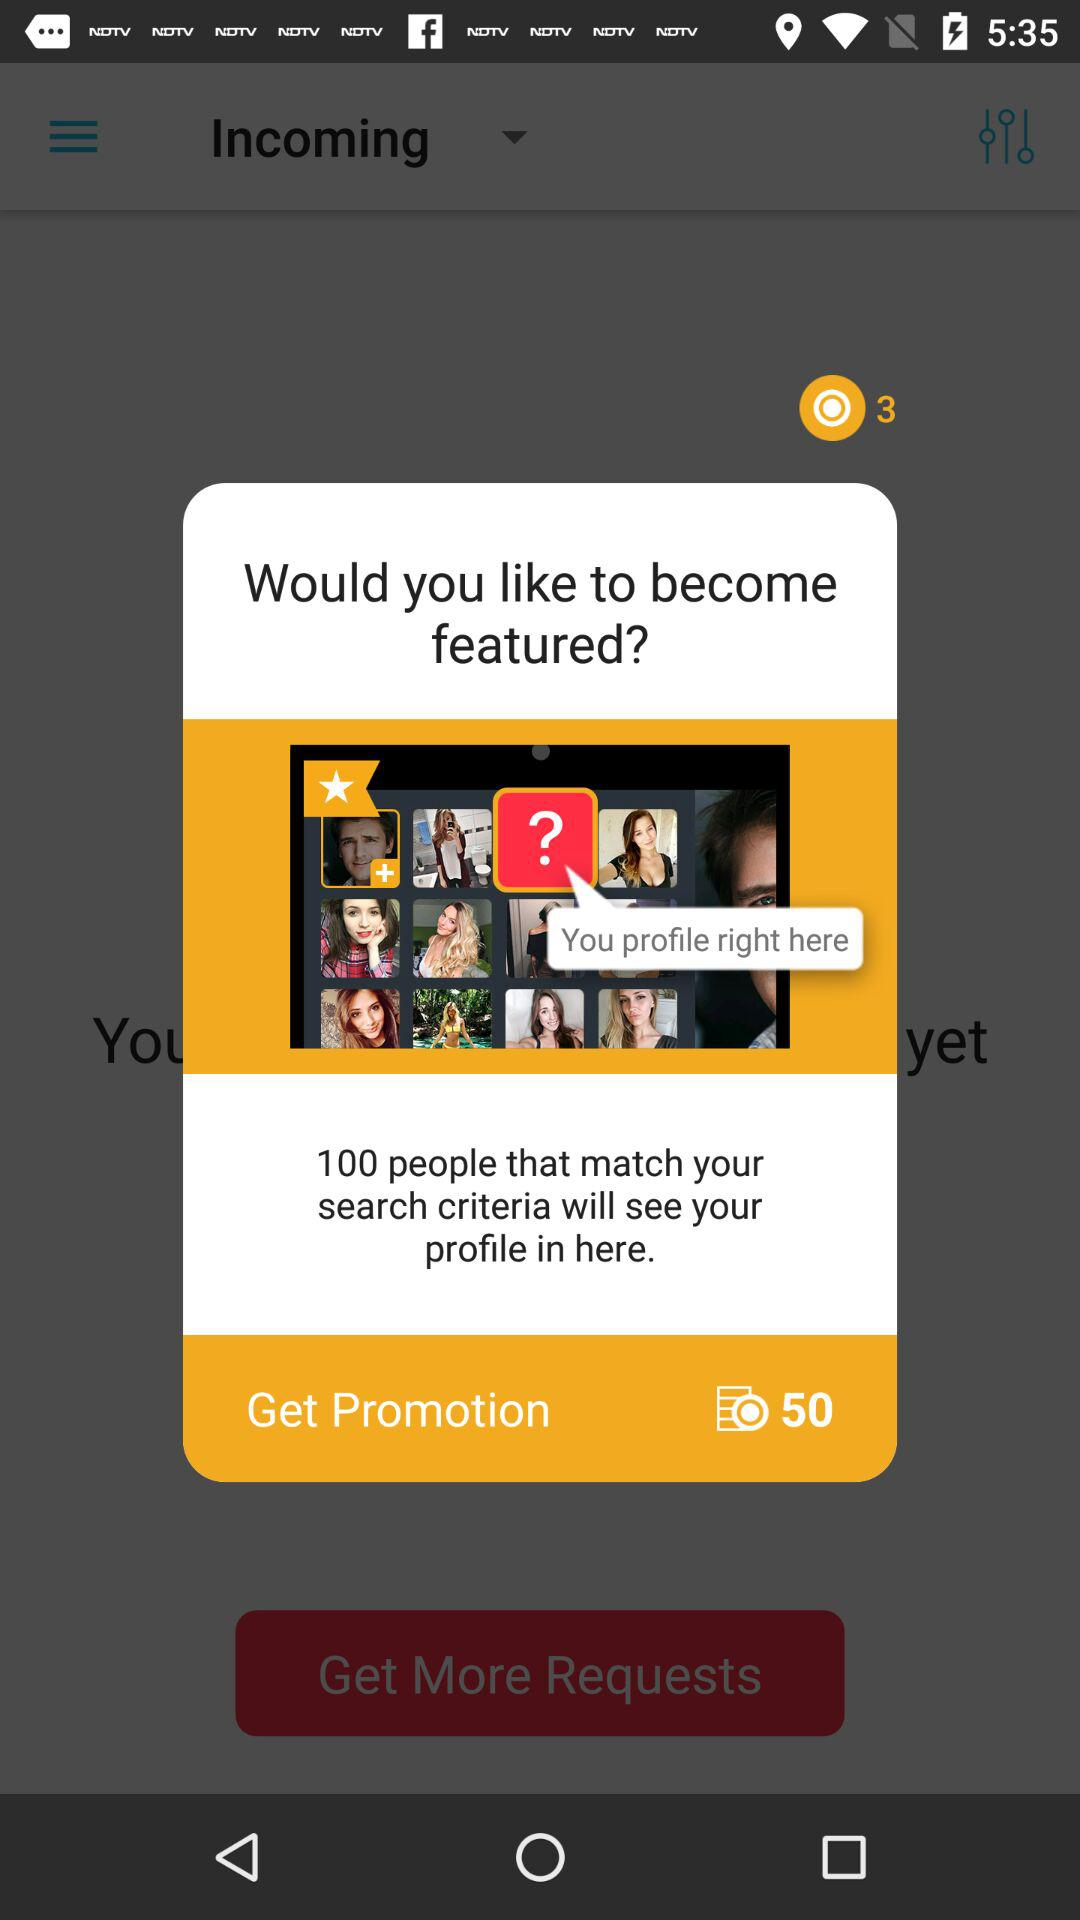How many more people will see your profile if you become featured?
Answer the question using a single word or phrase. 100 